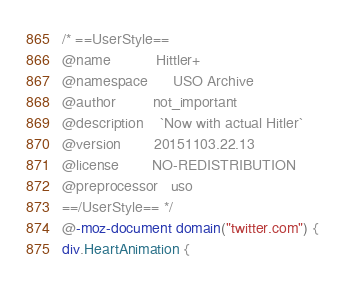Convert code to text. <code><loc_0><loc_0><loc_500><loc_500><_CSS_>/* ==UserStyle==
@name           Hittler+
@namespace      USO Archive
@author         not_important
@description    `Now with actual Hitler`
@version        20151103.22.13
@license        NO-REDISTRIBUTION
@preprocessor   uso
==/UserStyle== */
@-moz-document domain("twitter.com") {
div.HeartAnimation {</code> 